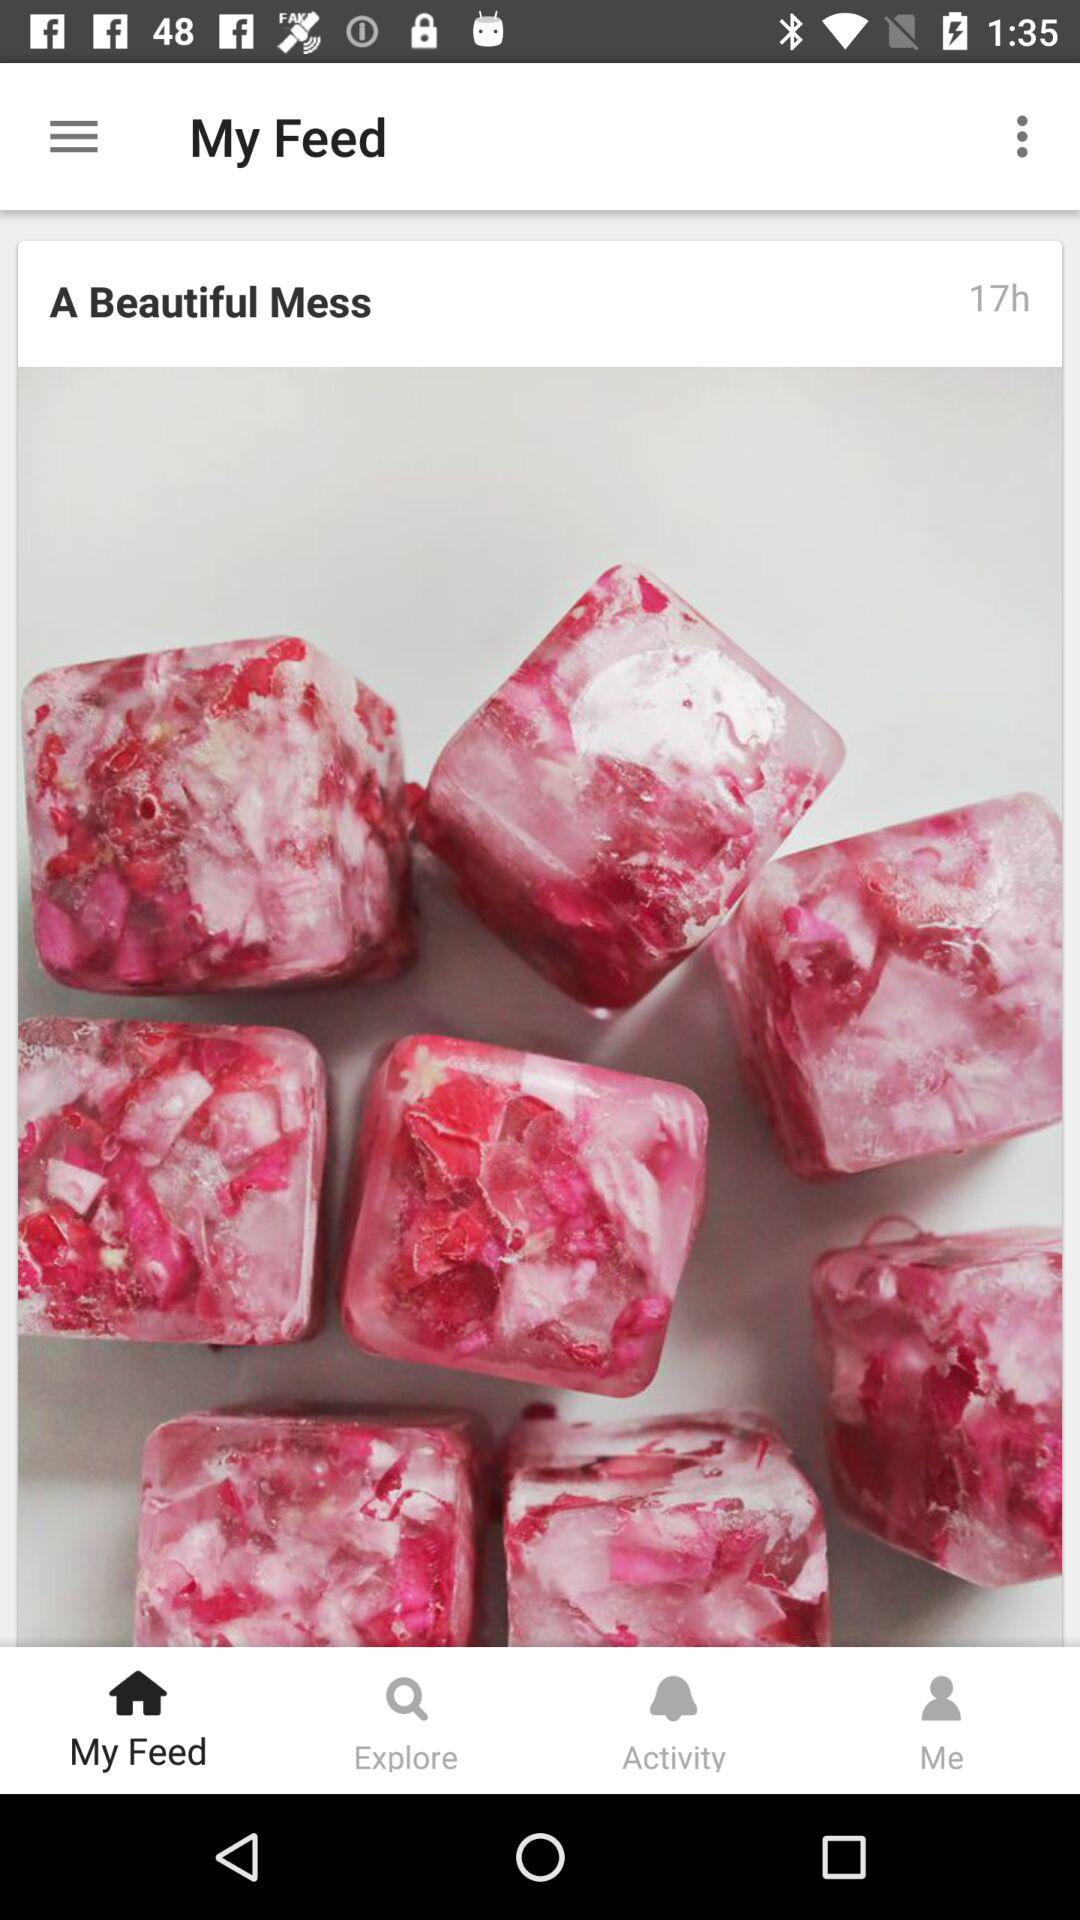How many hours ago was the post published?
Answer the question using a single word or phrase. 17 